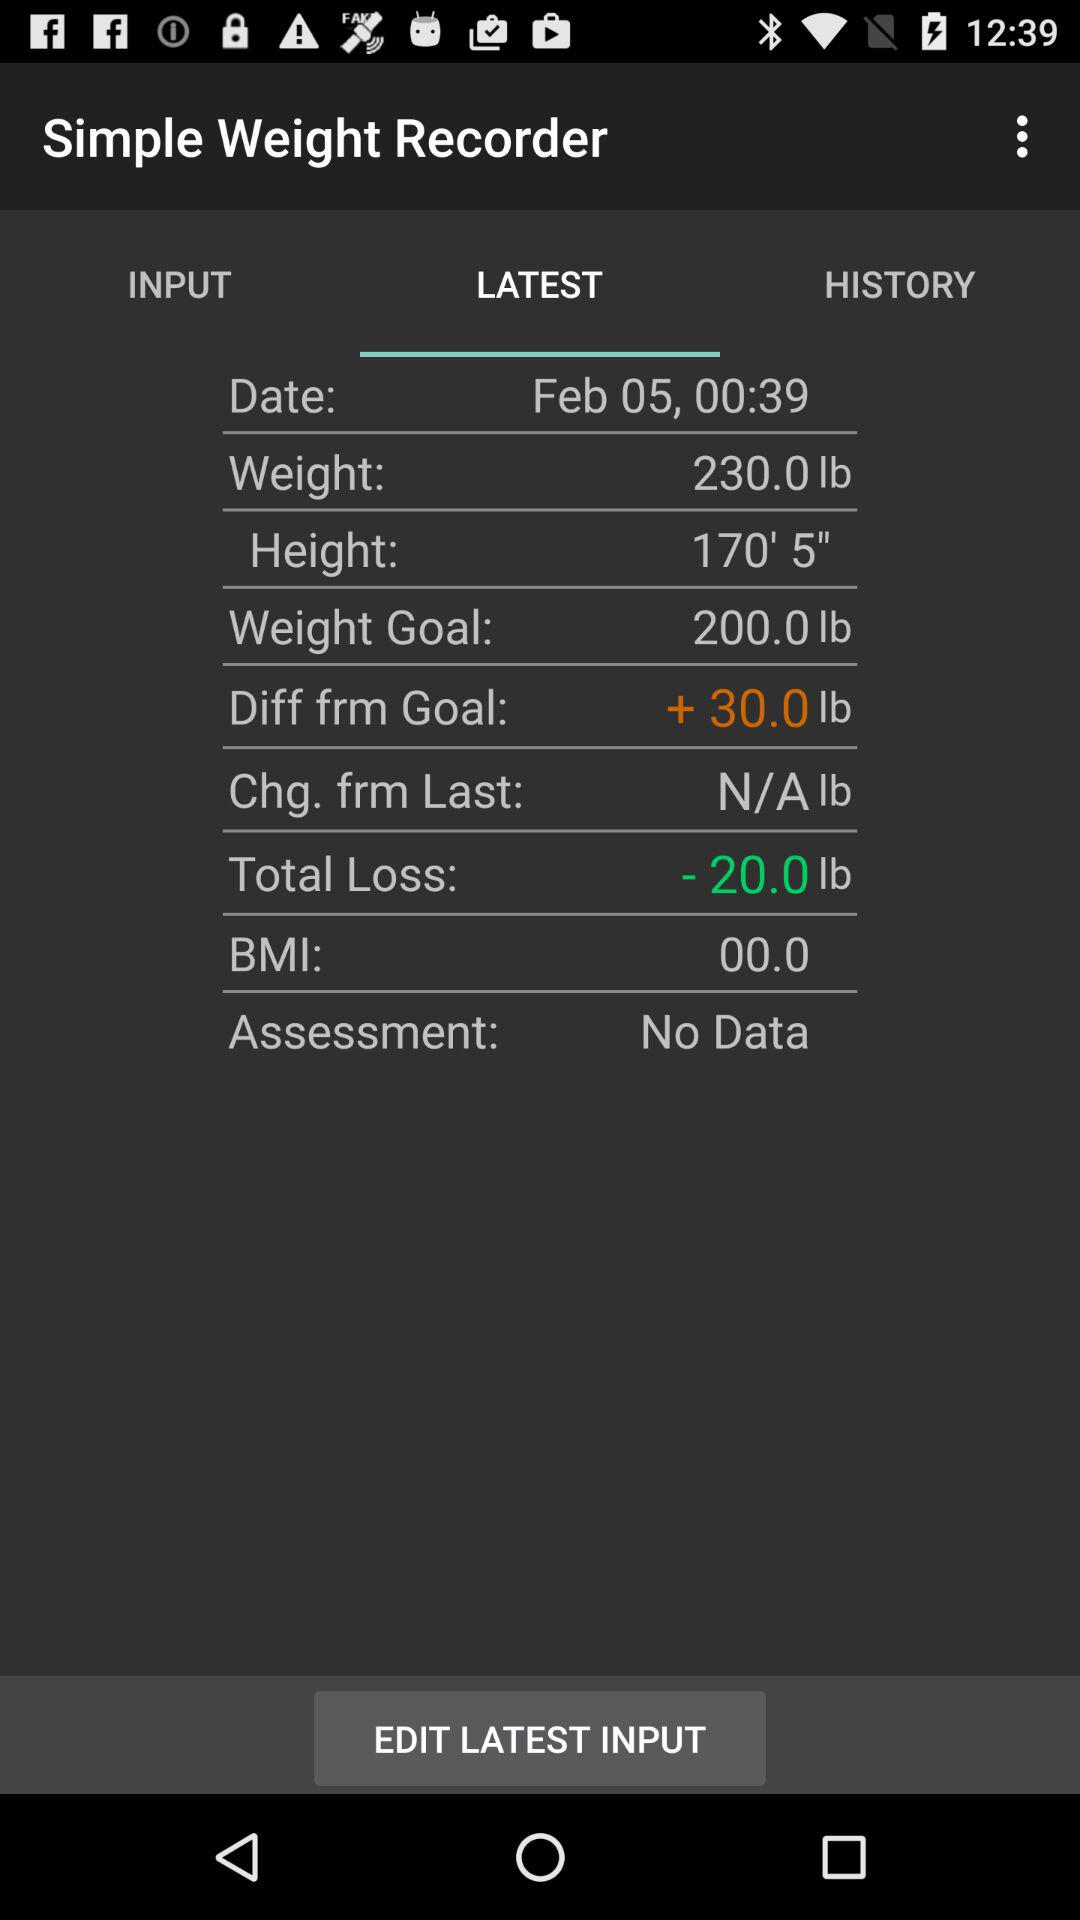What is the weight? The weight is 230 pounds. 